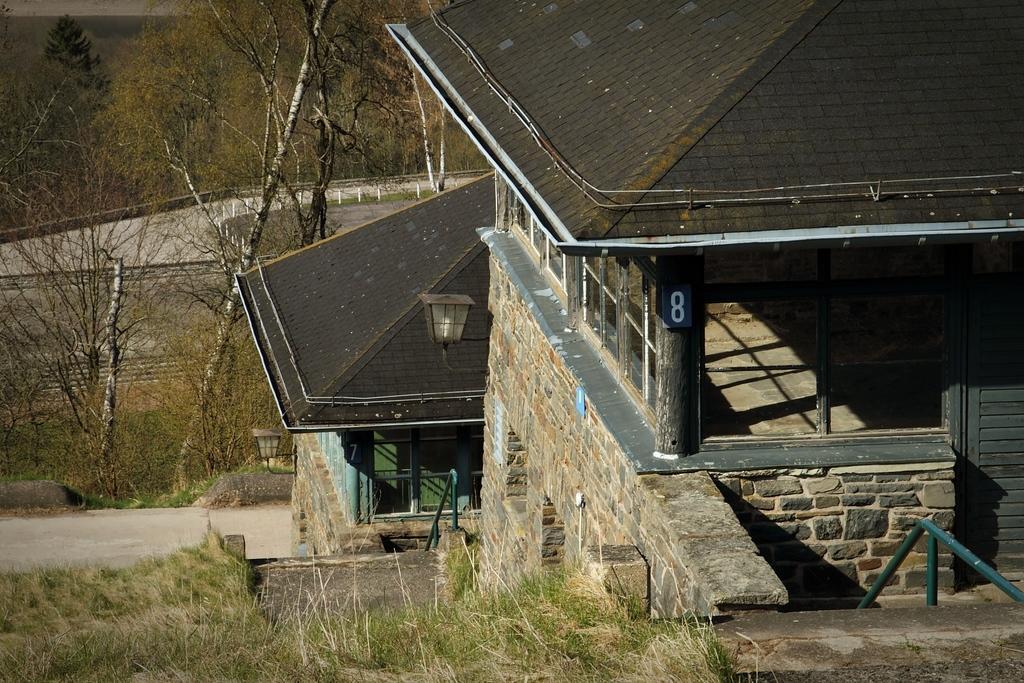In one or two sentences, can you explain what this image depicts? On the right side of the image there are some buildings. On the left side of the image there are some trees and grass and fencing. On the building there are two lights. 